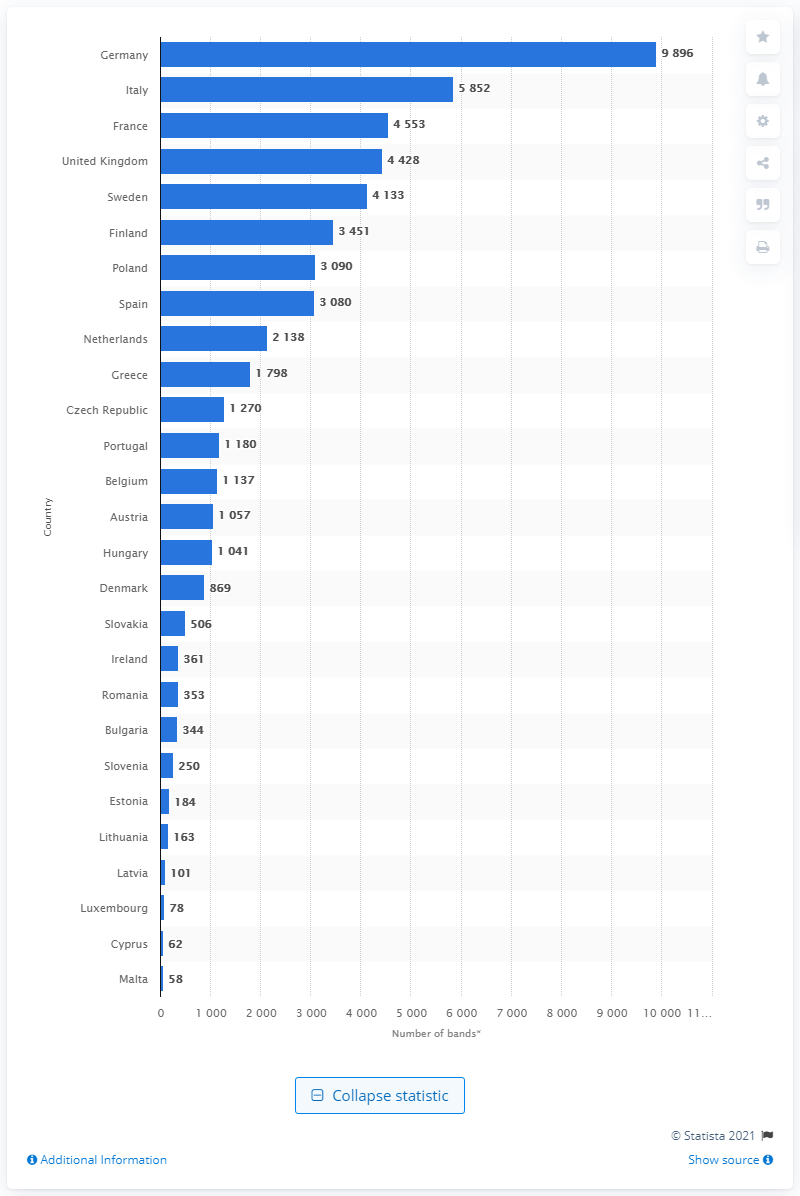Give some essential details in this illustration. As of July 2015, there were 62 metal bands located in Cyprus. 